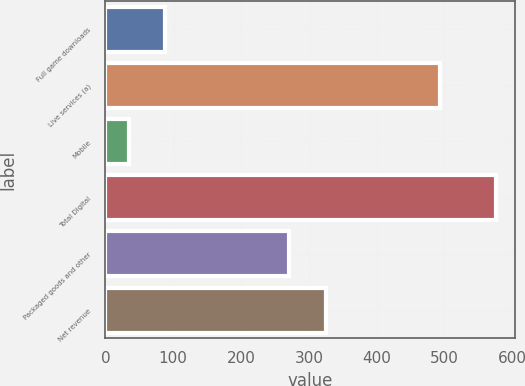Convert chart. <chart><loc_0><loc_0><loc_500><loc_500><bar_chart><fcel>Full game downloads<fcel>Live services (a)<fcel>Mobile<fcel>Total Digital<fcel>Packaged goods and other<fcel>Net revenue<nl><fcel>88.2<fcel>494<fcel>34<fcel>576<fcel>271<fcel>325.2<nl></chart> 